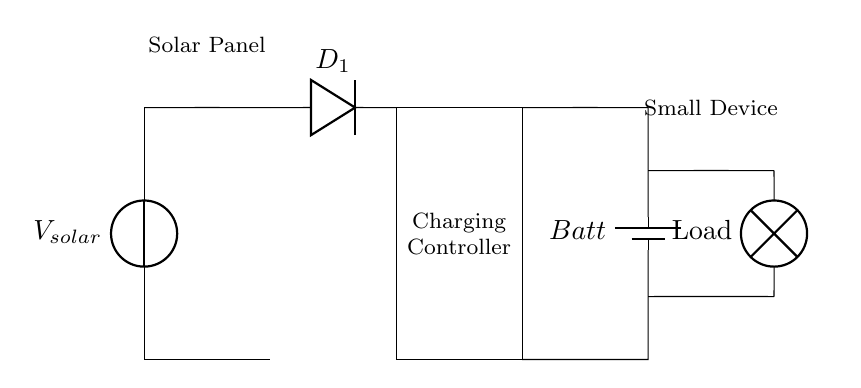What is the main component that converts solar energy into electrical energy? The main component that converts solar energy into electrical energy is the solar panel. It's shown at the leftmost part of the circuit diagram and is indicated as the voltage source.
Answer: Solar Panel What type of component is D1 in the circuit? D1 is a diode, which is indicated by the symbol next to it. Diodes allow current to flow in one direction, which is important for protecting the circuit.
Answer: Diode How many main components are there in this circuit diagram? The circuit diagram contains four main components: the solar panel, diode, charging controller, and battery. Each component serves a distinct purpose for the operation of the circuit.
Answer: Four What is the purpose of the charging controller in the circuit? The charging controller regulates the voltage and current coming from the solar panel to ensure safe charging of the battery. It helps prevent overcharging and maintains battery health.
Answer: Regulates charging Which component is used to power small devices in this circuit? The component used to power small devices is the battery, as it stores the energy collected from the solar panel for later use by appliances. It is positioned towards the right before the load.
Answer: Battery What is the flow direction of current in this circuit starting from the solar panel? The current flows from the solar panel to the diode, then to the charging controller, and finally to the battery and load. This sequence is followed due to the way the components are connected in the circuit diagram.
Answer: From solar panel to load What is the load device in this solar-powered circuit? The load device in this circuit is represented by a lamp. It is the component that utilizes the stored energy from the battery to operate and provide light.
Answer: Lamp 